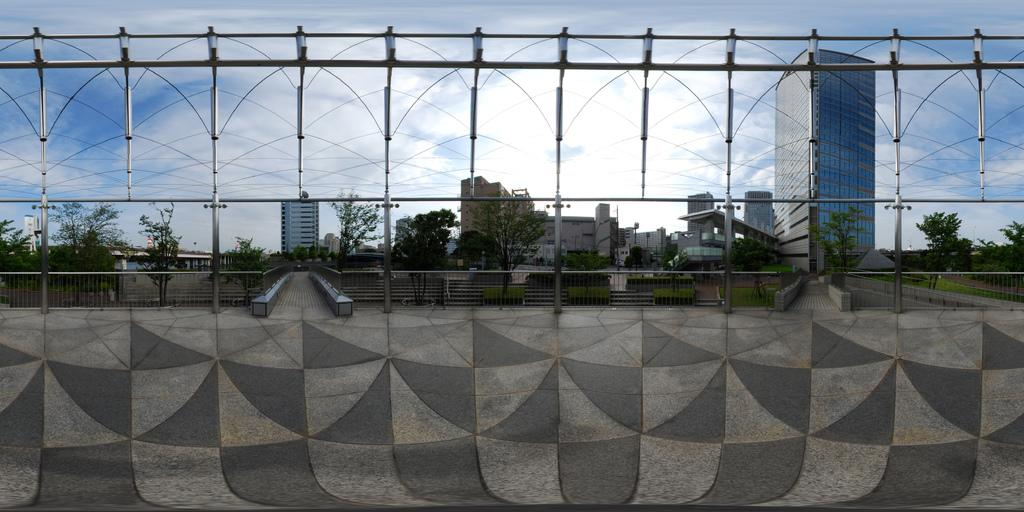What is located at the bottom of the image? There is a road at the bottom of the image. What structures can be seen in the image? There are poles, fences, and paths in the image. What type of vegetation is present in the image? There are trees and grass on the ground in the image. What can be seen in the background of the image? There are buildings, glass doors, and clouds in the sky in the background of the image. What type of steel structure can be seen in the image? There is no steel structure present in the image. Can you describe the twig that is being used as a walking stick by the person in the image? There is no person or walking stick present in the image. 